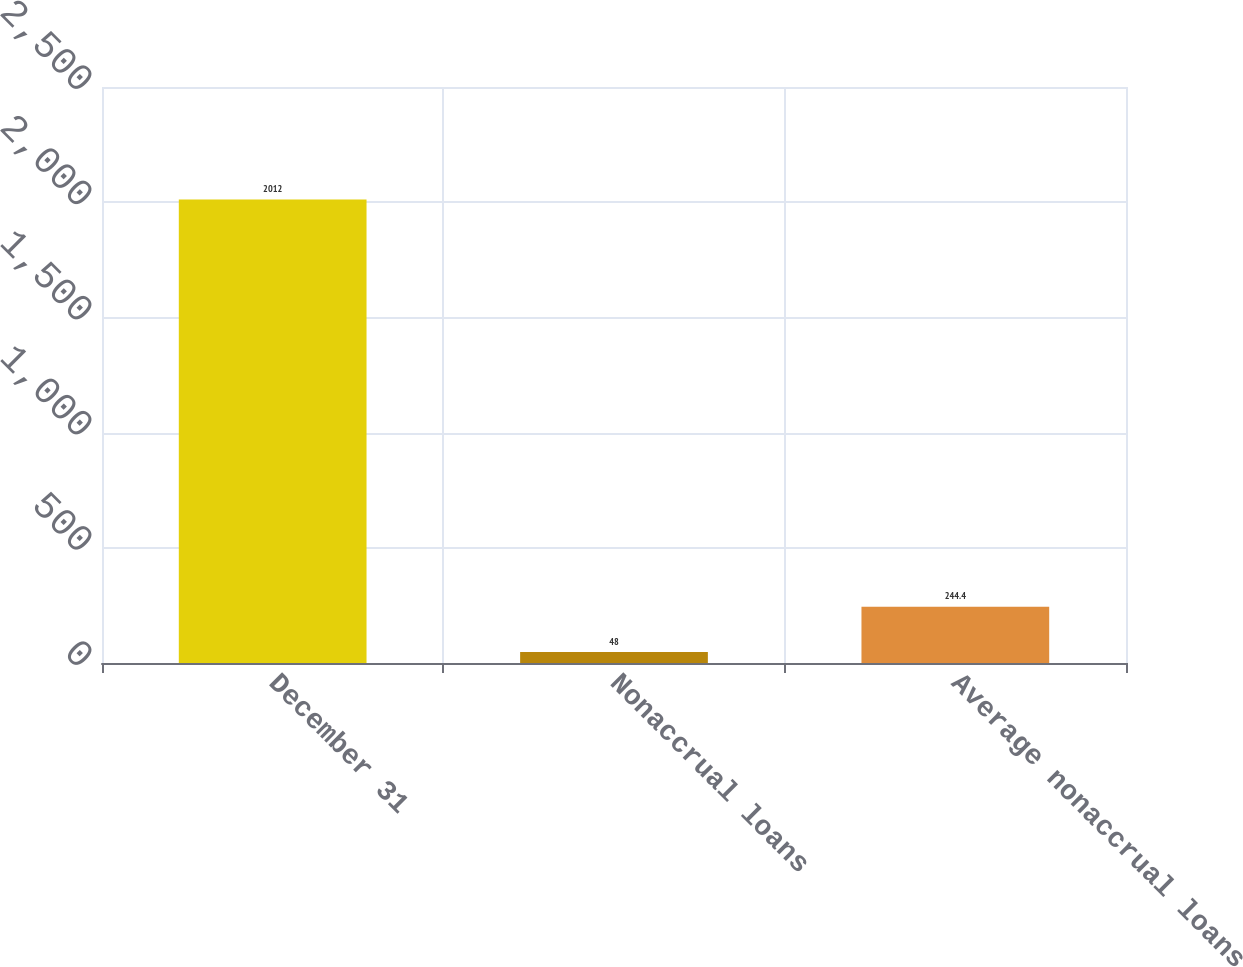Convert chart to OTSL. <chart><loc_0><loc_0><loc_500><loc_500><bar_chart><fcel>December 31<fcel>Nonaccrual loans<fcel>Average nonaccrual loans<nl><fcel>2012<fcel>48<fcel>244.4<nl></chart> 